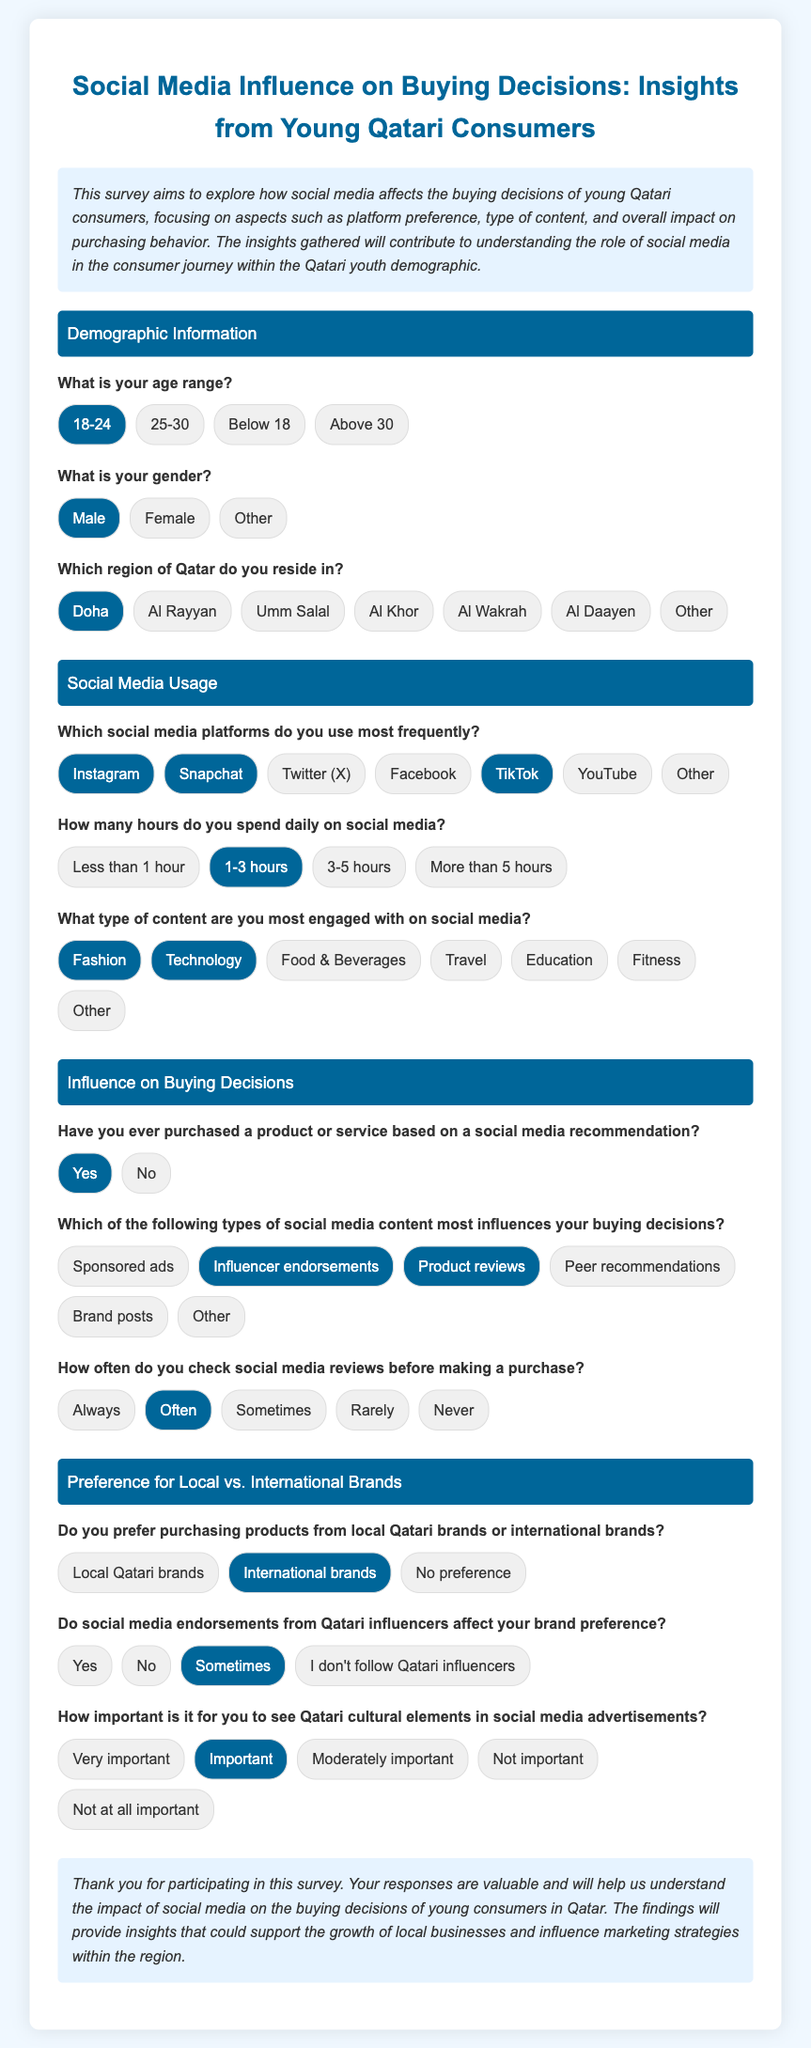What is the age range of the respondent? The selected age range is indicated in the survey as 18-24.
Answer: 18-24 What gender does the respondent identify as? The selected gender category in the survey reflects the respondent's choice, which is Male.
Answer: Male Which social media platforms does the respondent use most frequently? The selected platforms that the respondent uses most frequently include Instagram, Snapchat, and TikTok.
Answer: Instagram, Snapchat, TikTok How many hours does the respondent spend daily on social media? According to the survey response, the selected time spent on social media is 1-3 hours.
Answer: 1-3 hours What type of content is the respondent most engaged with on social media? The selected content types that the respondent is most engaged with include Fashion and Technology.
Answer: Fashion, Technology Which type of social media content most influences the respondent's buying decisions? The selected types of content that influence buying decisions are Influencer endorsements and Product reviews.
Answer: Influencer endorsements, Product reviews Does the respondent prefer local Qatari brands or international brands? The selected preference indicated in the survey is for International brands.
Answer: International brands How important is it for the respondent to see Qatari cultural elements in advertisements? The selected importance level for Qatari cultural elements in advertisements is Important.
Answer: Important How often does the respondent check social media reviews before making a purchase? The selected frequency of checking reviews indicated by the respondent is Often.
Answer: Often 